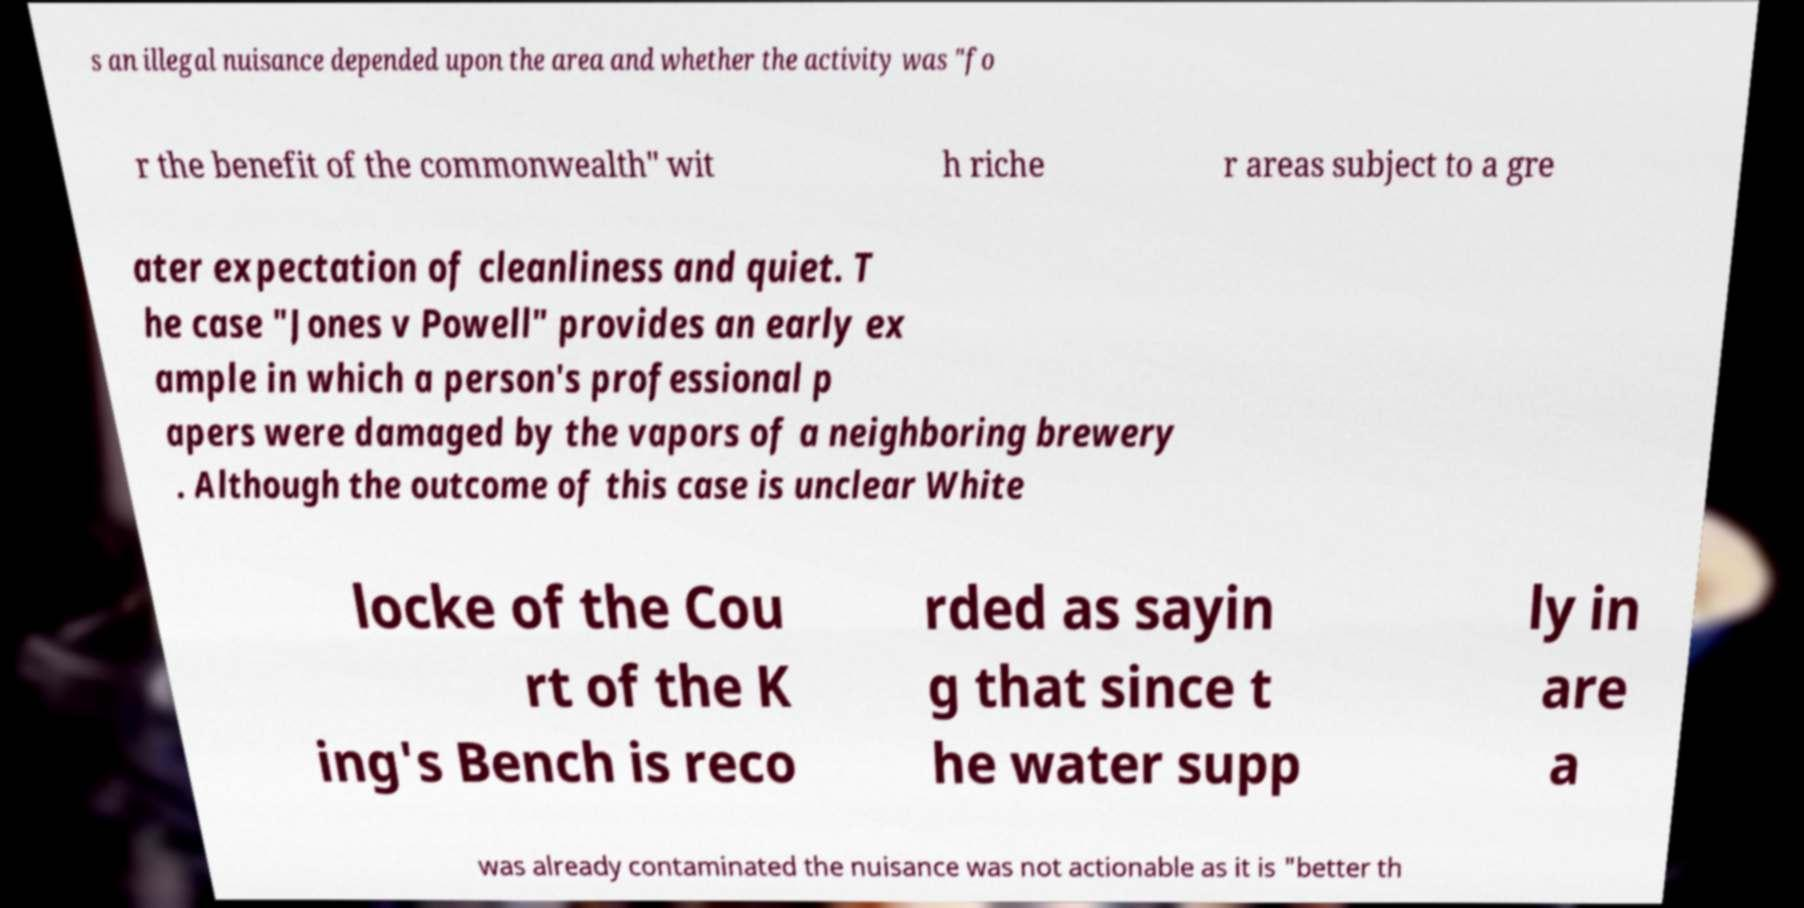Could you extract and type out the text from this image? s an illegal nuisance depended upon the area and whether the activity was "fo r the benefit of the commonwealth" wit h riche r areas subject to a gre ater expectation of cleanliness and quiet. T he case "Jones v Powell" provides an early ex ample in which a person's professional p apers were damaged by the vapors of a neighboring brewery . Although the outcome of this case is unclear White locke of the Cou rt of the K ing's Bench is reco rded as sayin g that since t he water supp ly in are a was already contaminated the nuisance was not actionable as it is "better th 